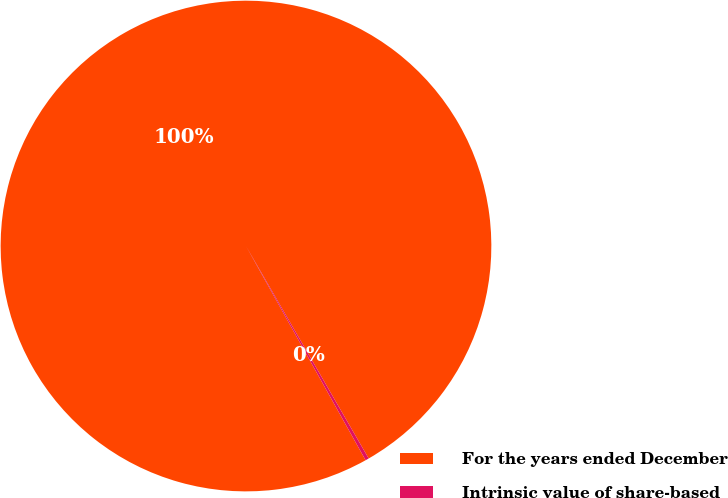<chart> <loc_0><loc_0><loc_500><loc_500><pie_chart><fcel>For the years ended December<fcel>Intrinsic value of share-based<nl><fcel>99.77%<fcel>0.23%<nl></chart> 